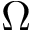Convert formula to latex. <formula><loc_0><loc_0><loc_500><loc_500>\Omega</formula> 